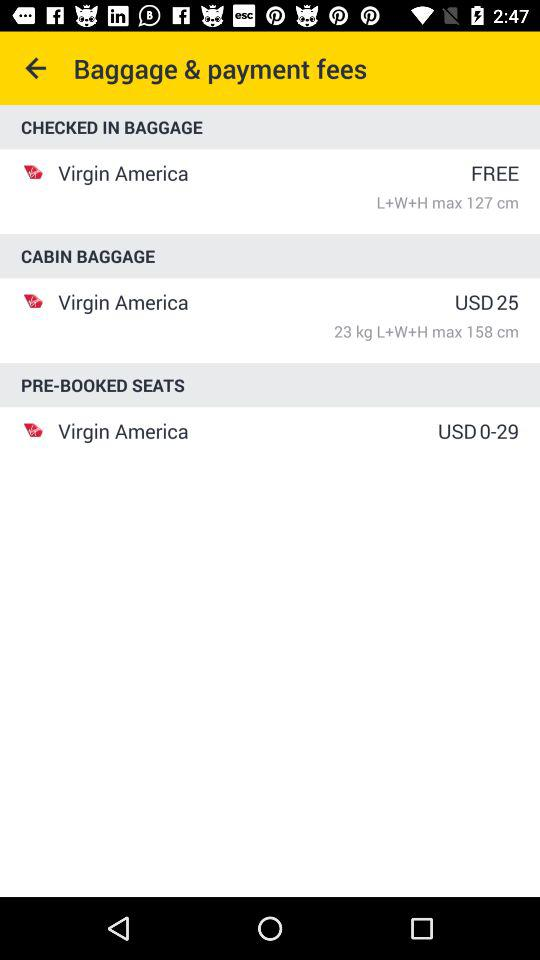What is the lowest payment?
When the provided information is insufficient, respond with <no answer>. <no answer> 